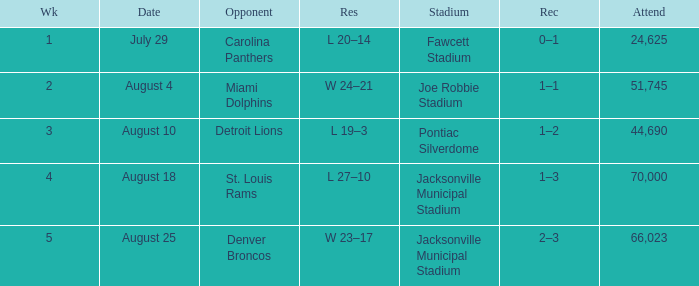WHEN has a Result of w 23–17? August 25. 